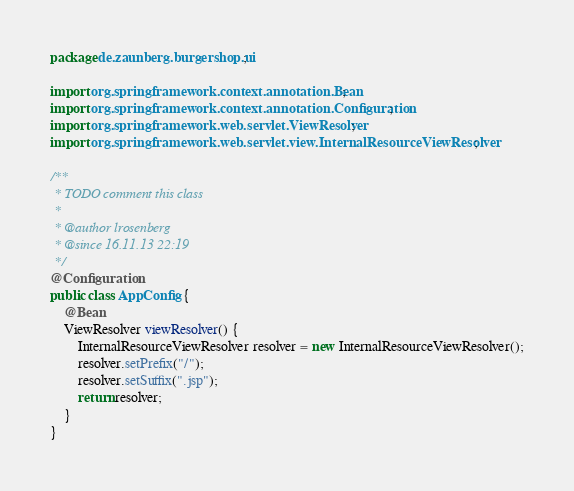<code> <loc_0><loc_0><loc_500><loc_500><_Java_>package de.zaunberg.burgershop.ui;

import org.springframework.context.annotation.Bean;
import org.springframework.context.annotation.Configuration;
import org.springframework.web.servlet.ViewResolver;
import org.springframework.web.servlet.view.InternalResourceViewResolver;

/**
 * TODO comment this class
 *
 * @author lrosenberg
 * @since 16.11.13 22:19
 */
@Configuration
public class AppConfig {
	@Bean
	ViewResolver viewResolver() {
		InternalResourceViewResolver resolver = new InternalResourceViewResolver();
		resolver.setPrefix("/");
		resolver.setSuffix(".jsp");
		return resolver;
	}
}
</code> 